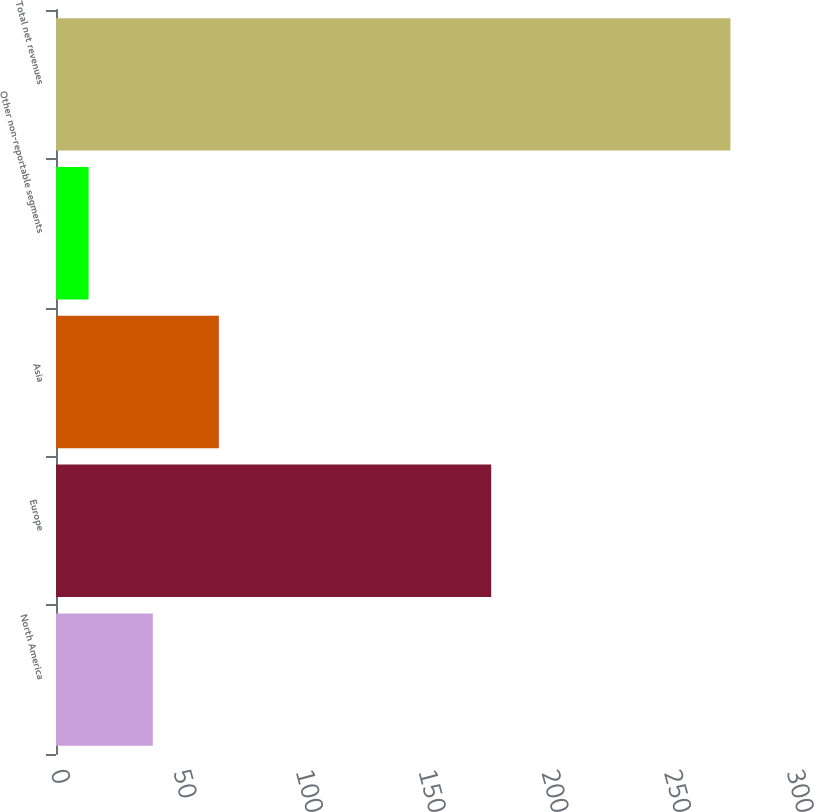<chart> <loc_0><loc_0><loc_500><loc_500><bar_chart><fcel>North America<fcel>Europe<fcel>Asia<fcel>Other non-reportable segments<fcel>Total net revenues<nl><fcel>39.46<fcel>177.4<fcel>66.4<fcel>13.3<fcel>274.9<nl></chart> 